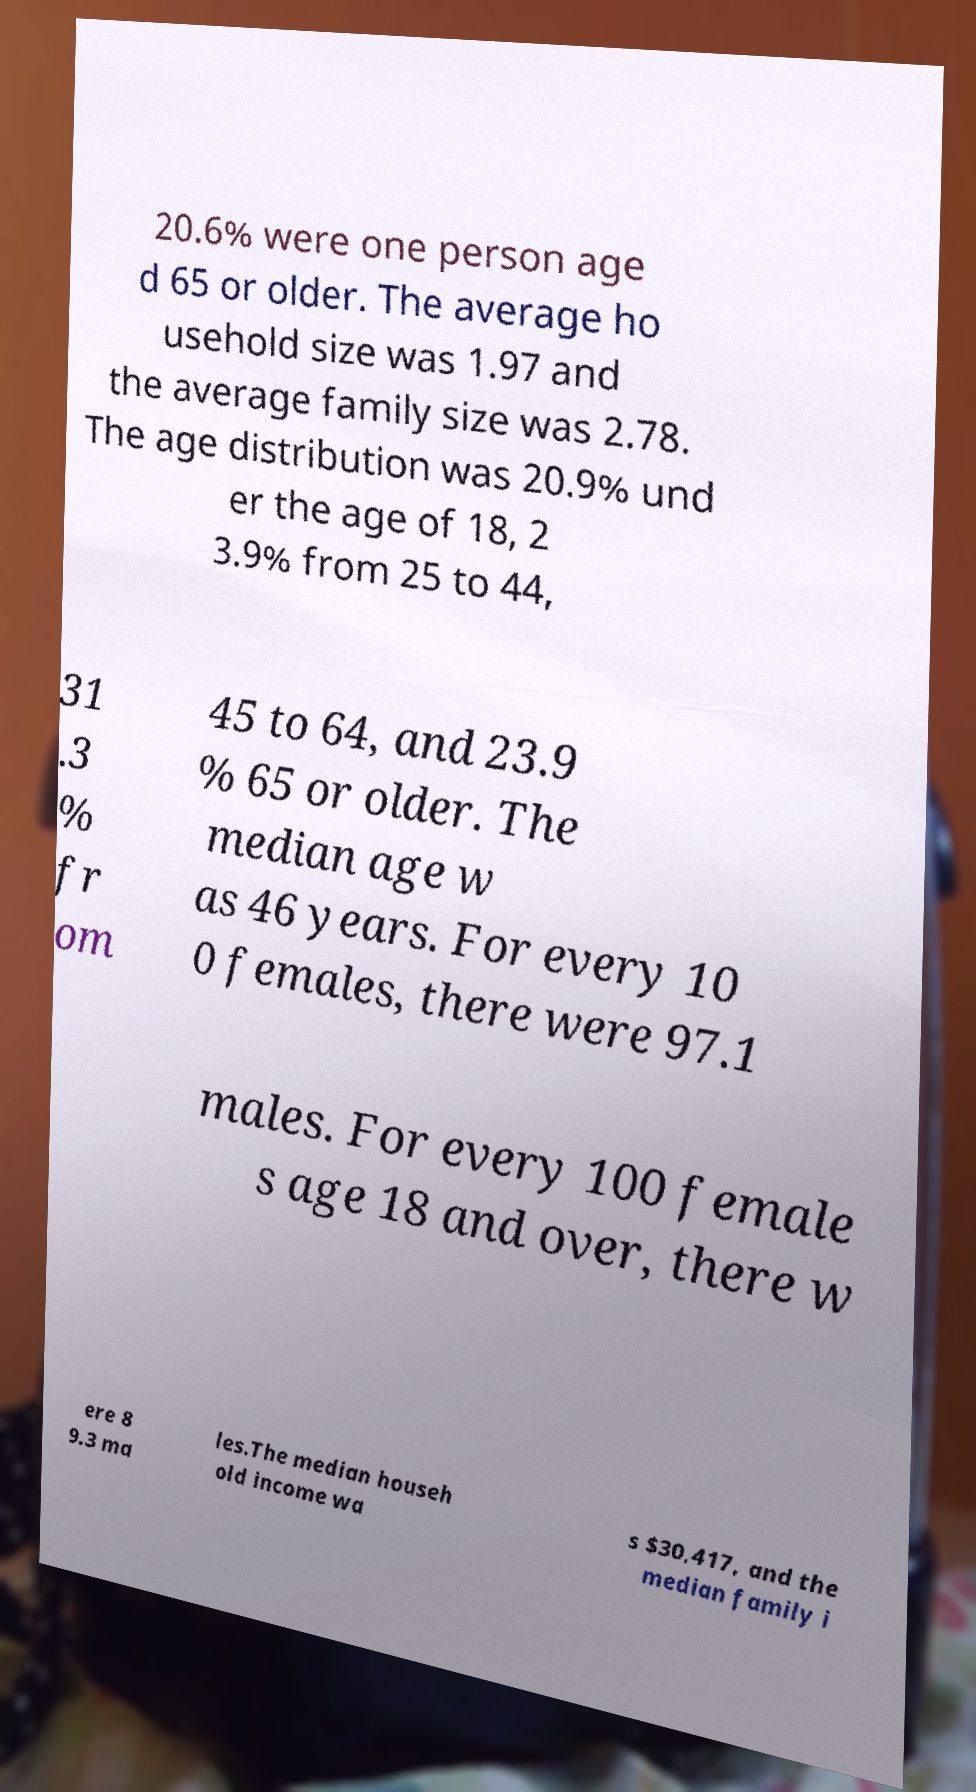Can you read and provide the text displayed in the image?This photo seems to have some interesting text. Can you extract and type it out for me? 20.6% were one person age d 65 or older. The average ho usehold size was 1.97 and the average family size was 2.78. The age distribution was 20.9% und er the age of 18, 2 3.9% from 25 to 44, 31 .3 % fr om 45 to 64, and 23.9 % 65 or older. The median age w as 46 years. For every 10 0 females, there were 97.1 males. For every 100 female s age 18 and over, there w ere 8 9.3 ma les.The median househ old income wa s $30,417, and the median family i 